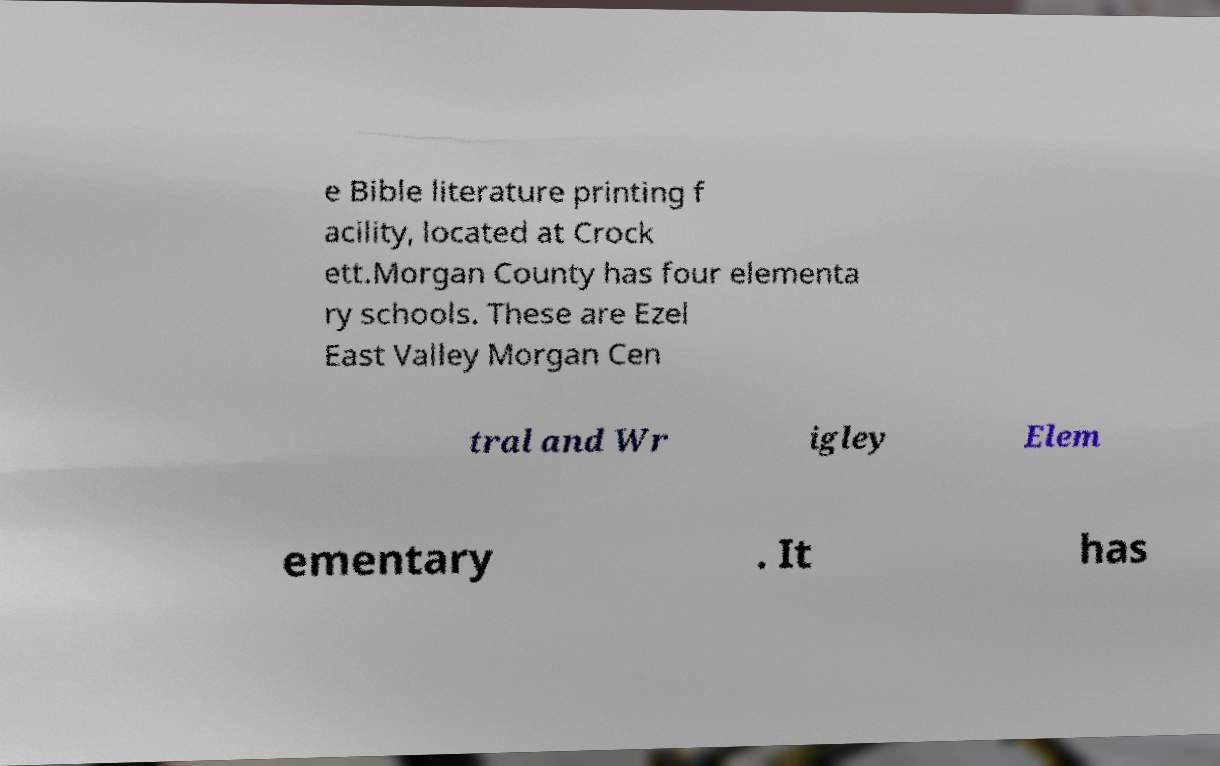I need the written content from this picture converted into text. Can you do that? e Bible literature printing f acility, located at Crock ett.Morgan County has four elementa ry schools. These are Ezel East Valley Morgan Cen tral and Wr igley Elem ementary . It has 